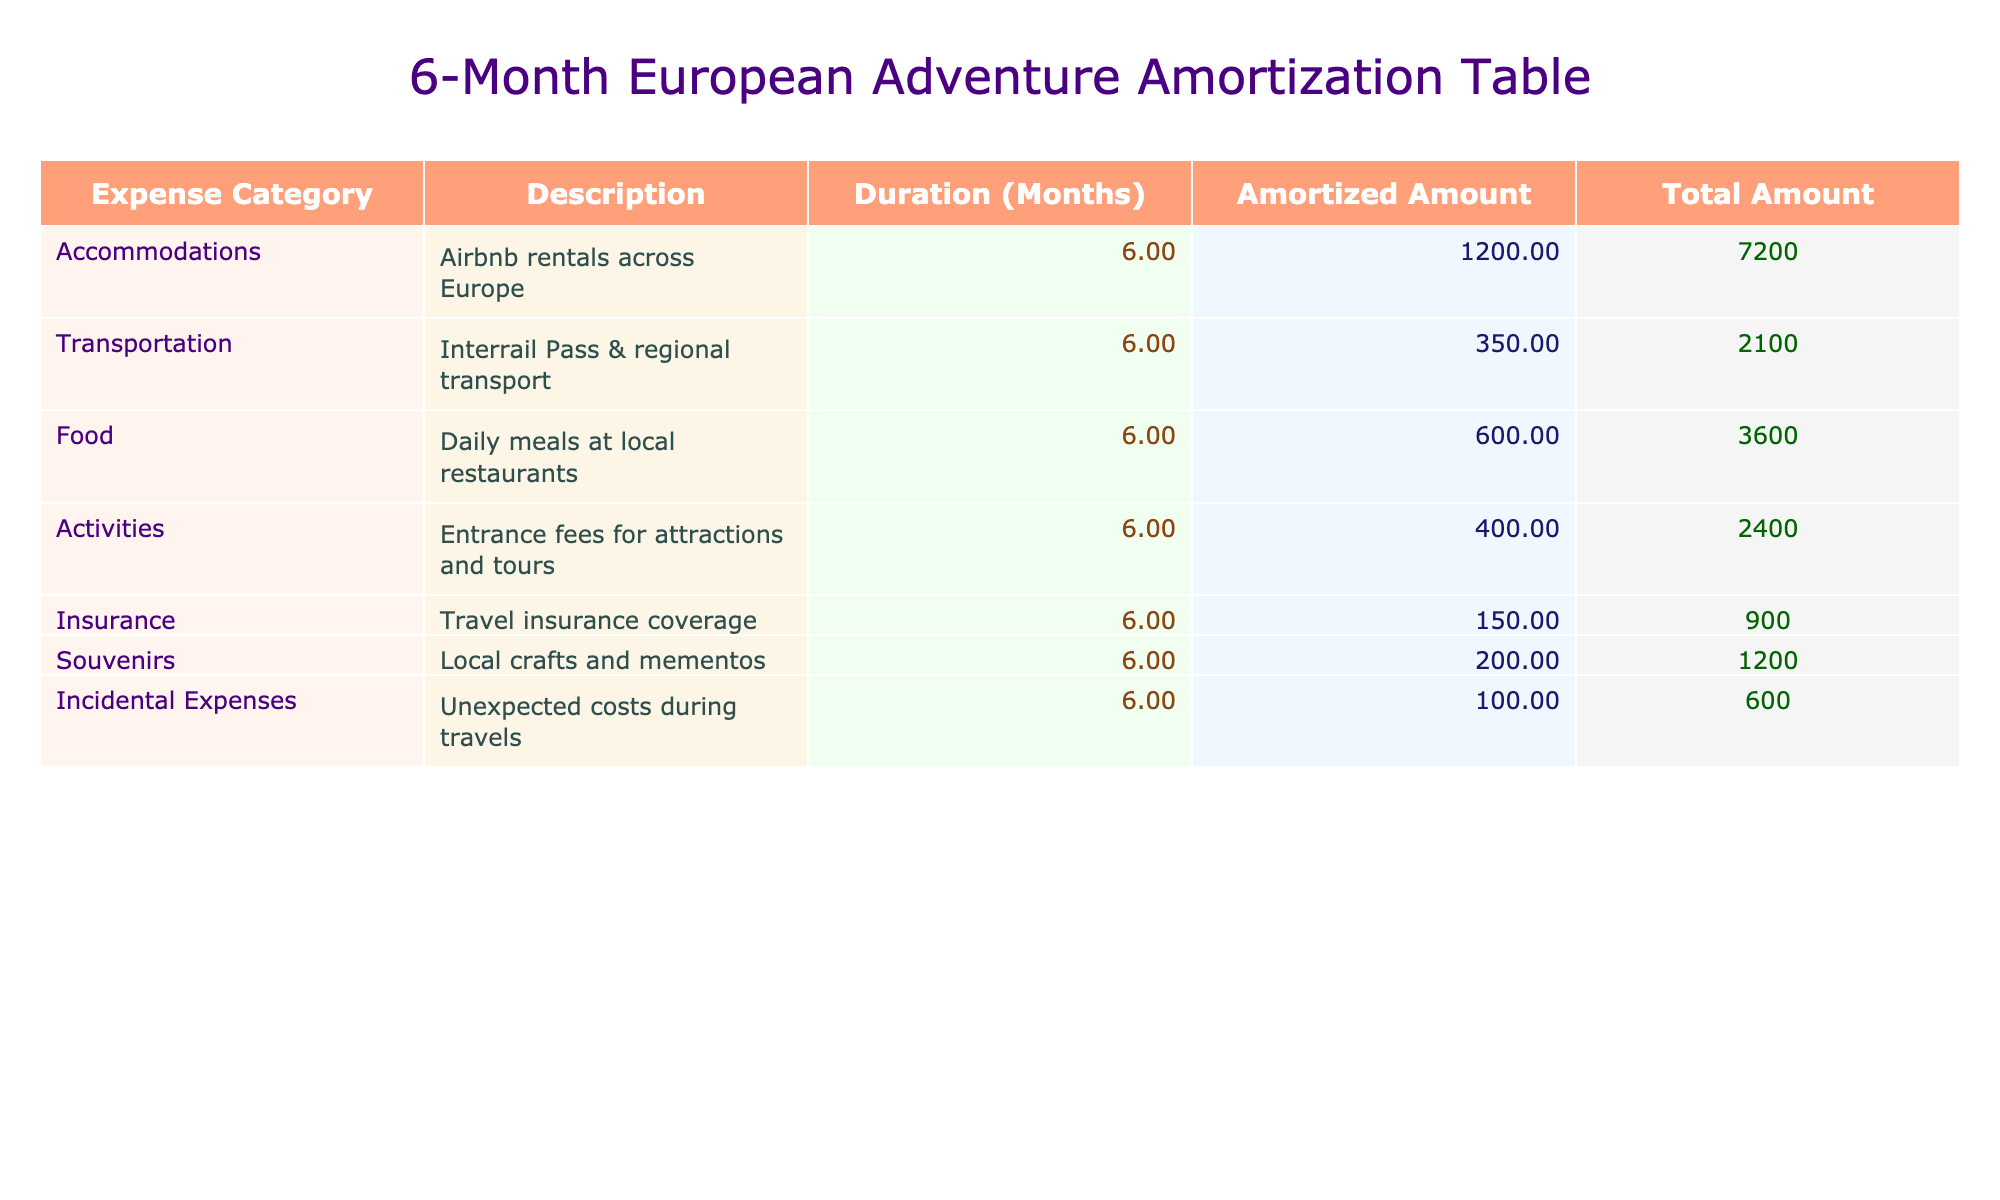What is the total amount spent on accommodations? The total amount spent on accommodations can be found in the "Total Amount (USD)" column next to "Accommodations." It is listed as 7200 USD.
Answer: 7200 USD What is the monthly amount allocated for food expenses? The monthly amount for food expenses is directly provided in the "Monthly Amount (USD)" column next to "Food." It is listed as 600 USD.
Answer: 600 USD Is the total amount for transportation higher than the total amount for insurance? The total amount for transportation is 2100 USD and for insurance, it is 900 USD. Since 2100 USD is greater than 900 USD, the statement is true.
Answer: Yes What is the total amount spent on incidental expenses and souvenirs combined? To find the total amount spent on incidental expenses, we look at its row, which is 600 USD. For souvenirs, we see it is 1200 USD. Adding both amounts together gives us 600 USD + 1200 USD = 1800 USD.
Answer: 1800 USD What is the average monthly expense across all categories? First, we sum the monthly amounts of all categories: 1200 + 350 + 600 + 400 + 150 + 200 + 100 = 3100 USD. Next, we divide by the number of categories, which is 7, so 3100 USD / 7 = approximately 442.86 USD.
Answer: 442.86 USD How much more is spent on activities compared to souvenirs? The amount spent on activities is 2400 USD while for souvenirs, it is 1200 USD. To find the difference, we subtract: 2400 USD - 1200 USD = 1200 USD.
Answer: 1200 USD Is the monthly amount for insurance greater than the monthly amount for transportation? The monthly amount for insurance is 150 USD, and for transportation, it is 350 USD. Since 150 USD is less than 350 USD, the statement is false.
Answer: No What percentage of the total adventure cost is attributed to food? The total amount for the adventure is the sum of all category totals: 7200 + 2100 + 3600 + 2400 + 900 + 1200 + 600 = 18000 USD. The amount spent on food is 3600 USD. The percentage is (3600 / 18000) * 100 = 20%.
Answer: 20% 